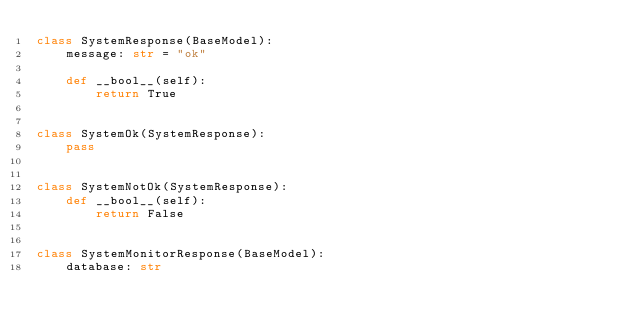Convert code to text. <code><loc_0><loc_0><loc_500><loc_500><_Python_>class SystemResponse(BaseModel):
    message: str = "ok"

    def __bool__(self):
        return True


class SystemOk(SystemResponse):
    pass


class SystemNotOk(SystemResponse):
    def __bool__(self):
        return False


class SystemMonitorResponse(BaseModel):
    database: str
</code> 